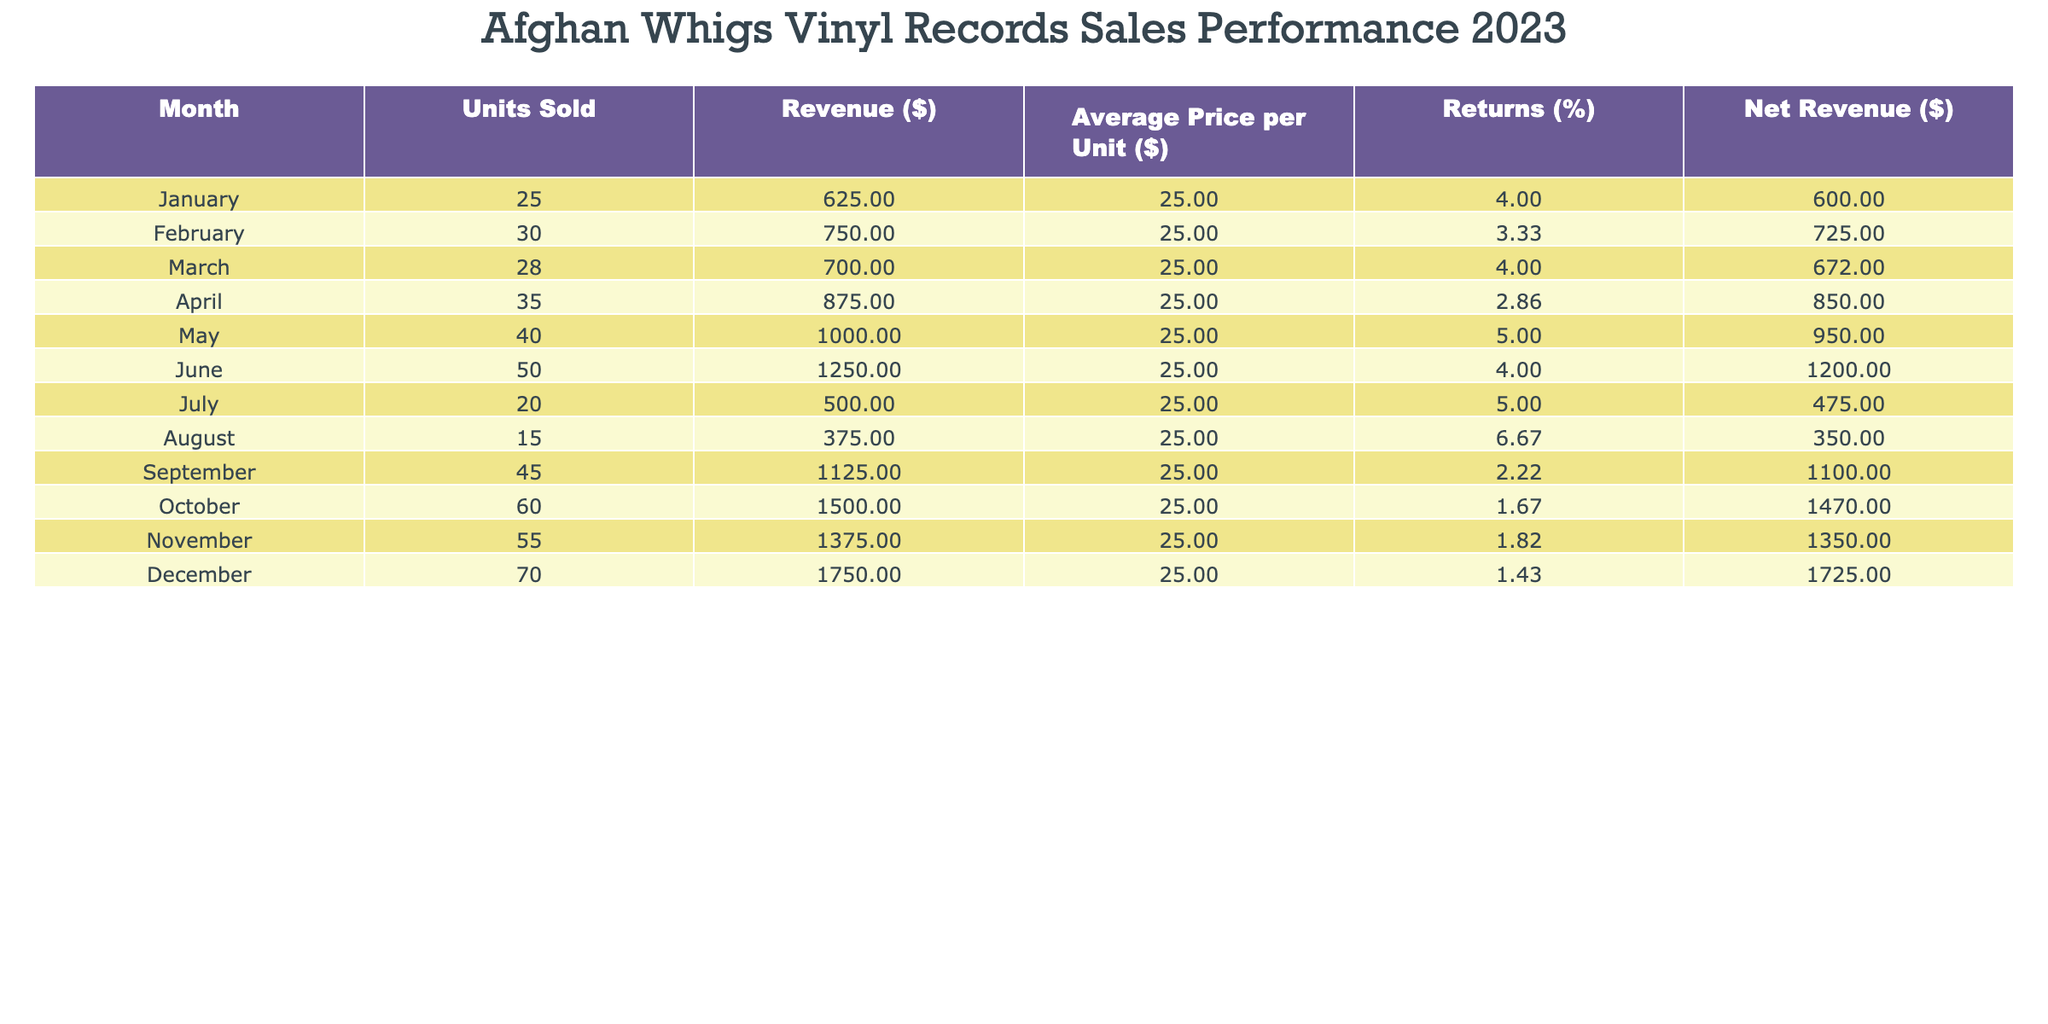What was the total revenue generated from sales of Afghan Whigs vinyl records in December 2023? The total revenue for December is listed in the table as $1750.
Answer: 1750 Which month had the highest number of units sold? By comparing the "Units Sold" column, December has the highest value at 70 units.
Answer: December What is the average revenue generated per month in 2023? To find the average revenue, sum all revenue values ($625 + $750 + $700 + $875 + $1000 + $1250 + $500 + $375 + $1125 + $1500 + $1375 + $1750 = 11625) and divide by 12, yielding an average of $968.75.
Answer: 968.75 Did the sales performance improve from January to June? Comparing units sold from January (25) to June (50), there is an increase of 25 units. Therefore, yes, performance improved.
Answer: Yes What was the percentage of returns in August 2023? The table shows that returns for August were 6.67%.
Answer: 6.67% Calculate the total net revenue for the first half of the year (January to June). The net revenues from January to June are: 600 + 725 + 672 + 850 + 950 + 1200 = 4097.
Answer: 4097 Was there any month in 2023 where the returns exceeded 5%? Yes, August and May both had returns over 5% (August 6.67%, May 5.00%).
Answer: Yes How much net revenue did you gain in September compared to July? Net revenue in September is $1100, while in July it is $475; thus, the gain is $1100 - $475 = $625.
Answer: 625 In which month did the overall returns percentage drop below 2%? The lowest returns percentage occurred in October (1.67%).
Answer: October 